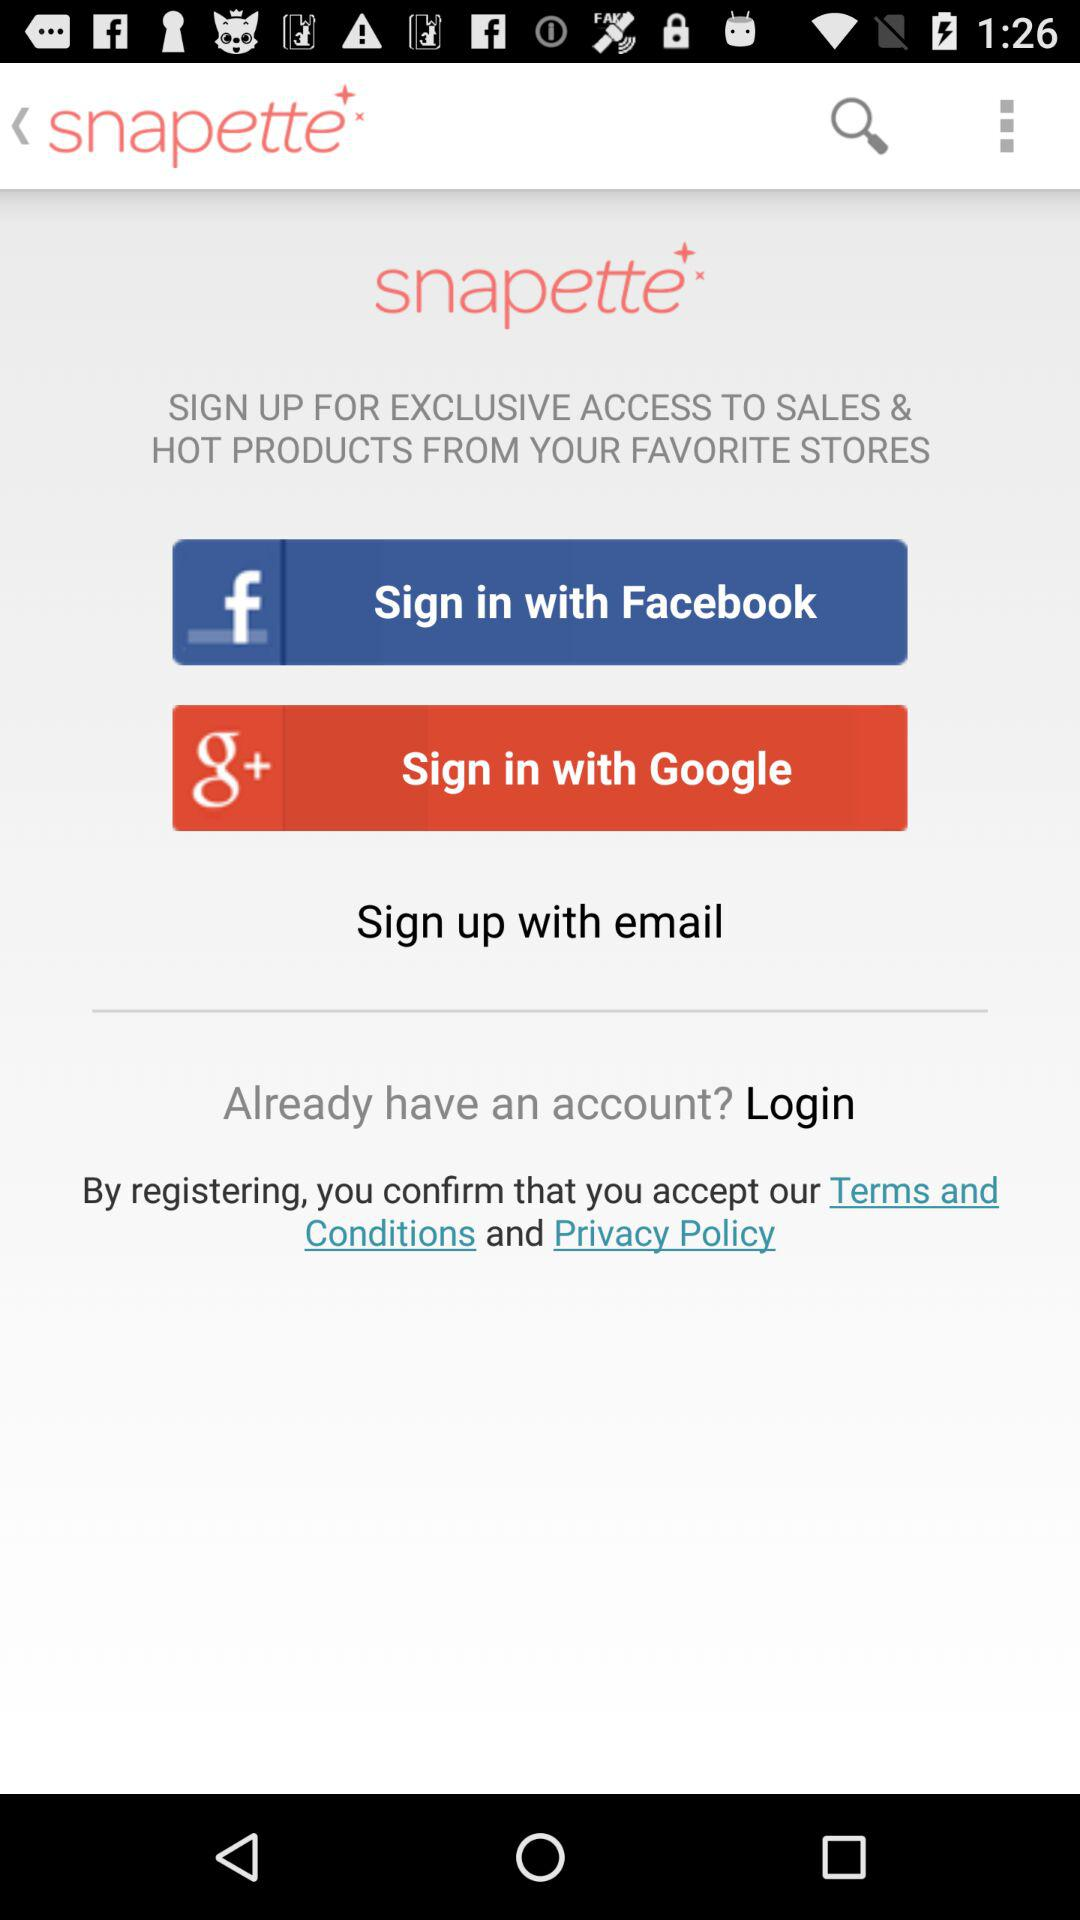What accounts can I use to sign up? The accounts that can be used to sign up are: "Sign up with email", "Sign in with Google", and "Sign up with email". 